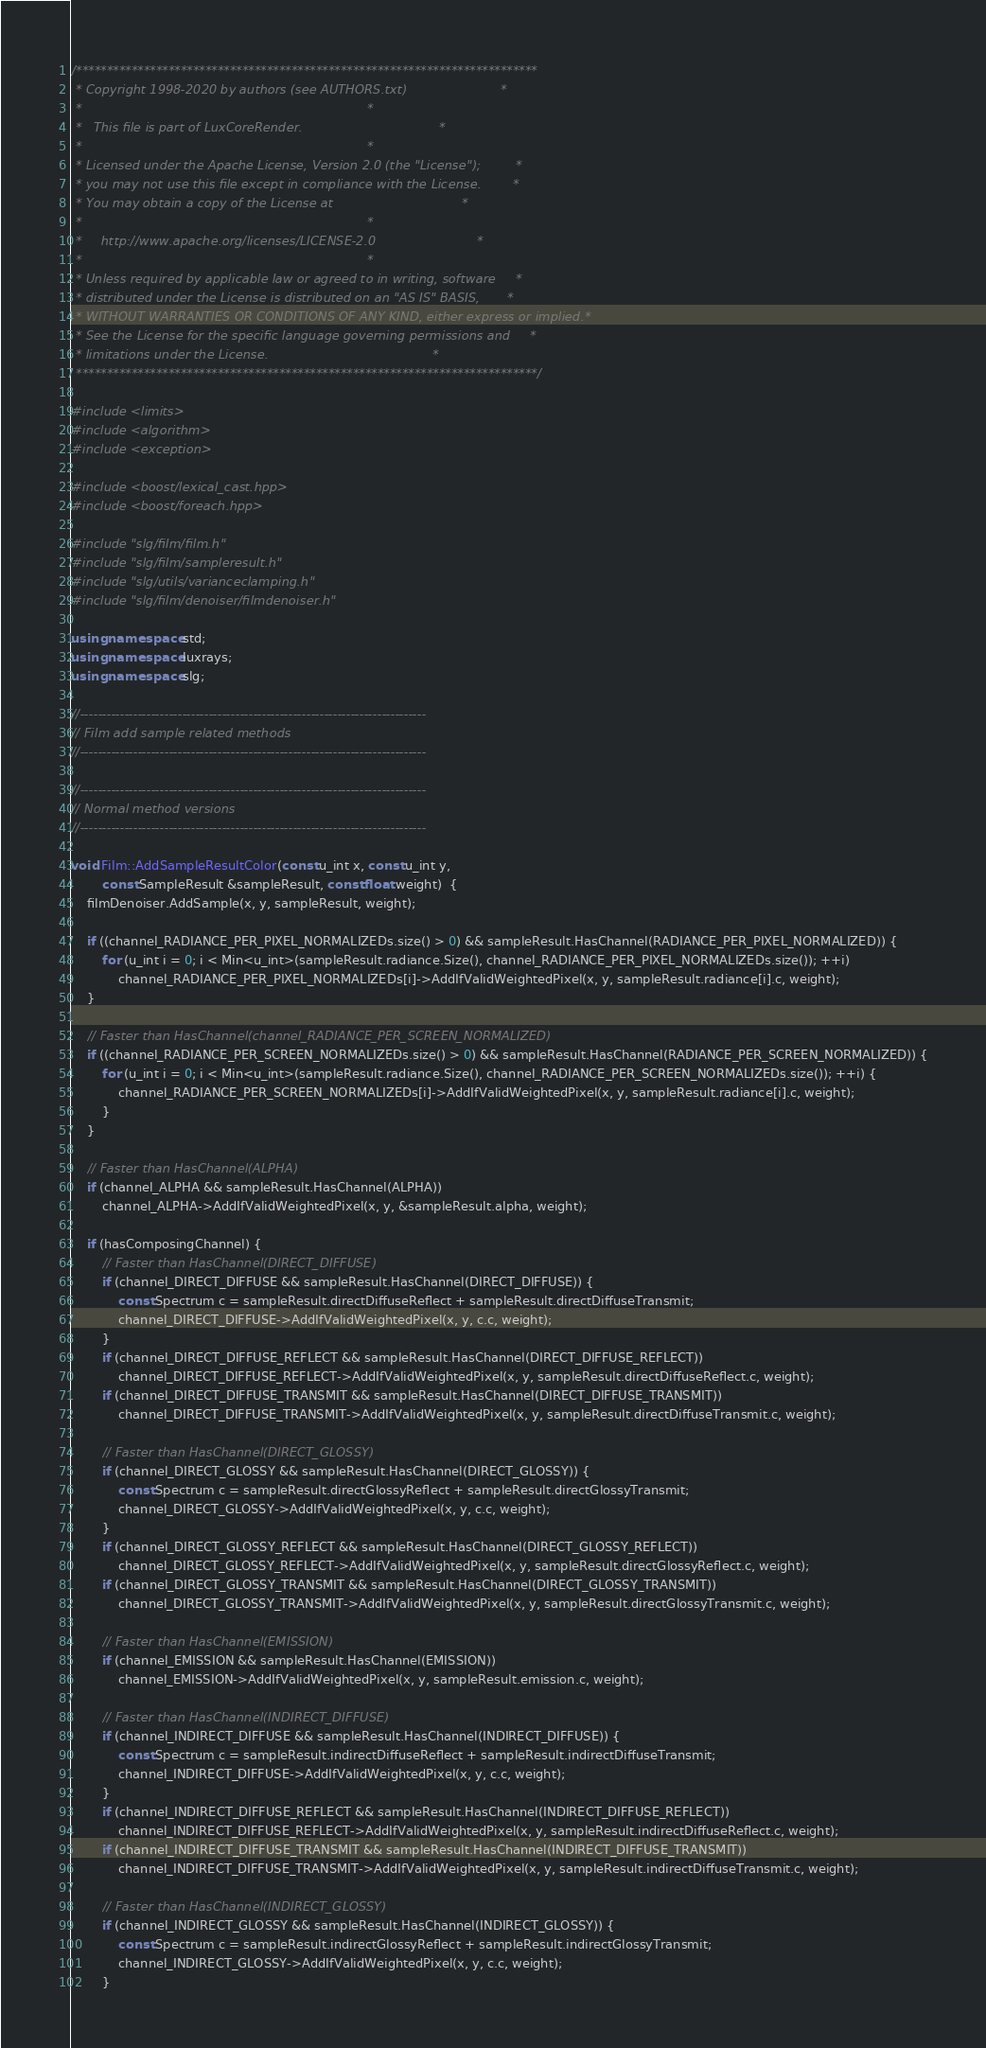<code> <loc_0><loc_0><loc_500><loc_500><_C++_>/***************************************************************************
 * Copyright 1998-2020 by authors (see AUTHORS.txt)                        *
 *                                                                         *
 *   This file is part of LuxCoreRender.                                   *
 *                                                                         *
 * Licensed under the Apache License, Version 2.0 (the "License");         *
 * you may not use this file except in compliance with the License.        *
 * You may obtain a copy of the License at                                 *
 *                                                                         *
 *     http://www.apache.org/licenses/LICENSE-2.0                          *
 *                                                                         *
 * Unless required by applicable law or agreed to in writing, software     *
 * distributed under the License is distributed on an "AS IS" BASIS,       *
 * WITHOUT WARRANTIES OR CONDITIONS OF ANY KIND, either express or implied.*
 * See the License for the specific language governing permissions and     *
 * limitations under the License.                                          *
 ***************************************************************************/

#include <limits>
#include <algorithm>
#include <exception>

#include <boost/lexical_cast.hpp>
#include <boost/foreach.hpp>

#include "slg/film/film.h"
#include "slg/film/sampleresult.h"
#include "slg/utils/varianceclamping.h"
#include "slg/film/denoiser/filmdenoiser.h"

using namespace std;
using namespace luxrays;
using namespace slg;

//------------------------------------------------------------------------------
// Film add sample related methods
//------------------------------------------------------------------------------

//------------------------------------------------------------------------------
// Normal method versions
//------------------------------------------------------------------------------

void Film::AddSampleResultColor(const u_int x, const u_int y,
		const SampleResult &sampleResult, const float weight)  {
	filmDenoiser.AddSample(x, y, sampleResult, weight);

	if ((channel_RADIANCE_PER_PIXEL_NORMALIZEDs.size() > 0) && sampleResult.HasChannel(RADIANCE_PER_PIXEL_NORMALIZED)) {
		for (u_int i = 0; i < Min<u_int>(sampleResult.radiance.Size(), channel_RADIANCE_PER_PIXEL_NORMALIZEDs.size()); ++i)
			channel_RADIANCE_PER_PIXEL_NORMALIZEDs[i]->AddIfValidWeightedPixel(x, y, sampleResult.radiance[i].c, weight);
	}

	// Faster than HasChannel(channel_RADIANCE_PER_SCREEN_NORMALIZED)
	if ((channel_RADIANCE_PER_SCREEN_NORMALIZEDs.size() > 0) && sampleResult.HasChannel(RADIANCE_PER_SCREEN_NORMALIZED)) {
		for (u_int i = 0; i < Min<u_int>(sampleResult.radiance.Size(), channel_RADIANCE_PER_SCREEN_NORMALIZEDs.size()); ++i) {
			channel_RADIANCE_PER_SCREEN_NORMALIZEDs[i]->AddIfValidWeightedPixel(x, y, sampleResult.radiance[i].c, weight);
		}
	}

	// Faster than HasChannel(ALPHA)
	if (channel_ALPHA && sampleResult.HasChannel(ALPHA))
		channel_ALPHA->AddIfValidWeightedPixel(x, y, &sampleResult.alpha, weight);

	if (hasComposingChannel) {
		// Faster than HasChannel(DIRECT_DIFFUSE)
		if (channel_DIRECT_DIFFUSE && sampleResult.HasChannel(DIRECT_DIFFUSE)) {
			const Spectrum c = sampleResult.directDiffuseReflect + sampleResult.directDiffuseTransmit;
			channel_DIRECT_DIFFUSE->AddIfValidWeightedPixel(x, y, c.c, weight);
		}
		if (channel_DIRECT_DIFFUSE_REFLECT && sampleResult.HasChannel(DIRECT_DIFFUSE_REFLECT))
			channel_DIRECT_DIFFUSE_REFLECT->AddIfValidWeightedPixel(x, y, sampleResult.directDiffuseReflect.c, weight);
		if (channel_DIRECT_DIFFUSE_TRANSMIT && sampleResult.HasChannel(DIRECT_DIFFUSE_TRANSMIT))
			channel_DIRECT_DIFFUSE_TRANSMIT->AddIfValidWeightedPixel(x, y, sampleResult.directDiffuseTransmit.c, weight);

		// Faster than HasChannel(DIRECT_GLOSSY)
		if (channel_DIRECT_GLOSSY && sampleResult.HasChannel(DIRECT_GLOSSY)) {
			const Spectrum c = sampleResult.directGlossyReflect + sampleResult.directGlossyTransmit;
			channel_DIRECT_GLOSSY->AddIfValidWeightedPixel(x, y, c.c, weight);
		}
		if (channel_DIRECT_GLOSSY_REFLECT && sampleResult.HasChannel(DIRECT_GLOSSY_REFLECT))
			channel_DIRECT_GLOSSY_REFLECT->AddIfValidWeightedPixel(x, y, sampleResult.directGlossyReflect.c, weight);
		if (channel_DIRECT_GLOSSY_TRANSMIT && sampleResult.HasChannel(DIRECT_GLOSSY_TRANSMIT))
			channel_DIRECT_GLOSSY_TRANSMIT->AddIfValidWeightedPixel(x, y, sampleResult.directGlossyTransmit.c, weight);

		// Faster than HasChannel(EMISSION)
		if (channel_EMISSION && sampleResult.HasChannel(EMISSION))
			channel_EMISSION->AddIfValidWeightedPixel(x, y, sampleResult.emission.c, weight);

		// Faster than HasChannel(INDIRECT_DIFFUSE)
		if (channel_INDIRECT_DIFFUSE && sampleResult.HasChannel(INDIRECT_DIFFUSE)) {
			const Spectrum c = sampleResult.indirectDiffuseReflect + sampleResult.indirectDiffuseTransmit;
			channel_INDIRECT_DIFFUSE->AddIfValidWeightedPixel(x, y, c.c, weight);
		}
		if (channel_INDIRECT_DIFFUSE_REFLECT && sampleResult.HasChannel(INDIRECT_DIFFUSE_REFLECT))
			channel_INDIRECT_DIFFUSE_REFLECT->AddIfValidWeightedPixel(x, y, sampleResult.indirectDiffuseReflect.c, weight);
		if (channel_INDIRECT_DIFFUSE_TRANSMIT && sampleResult.HasChannel(INDIRECT_DIFFUSE_TRANSMIT))
			channel_INDIRECT_DIFFUSE_TRANSMIT->AddIfValidWeightedPixel(x, y, sampleResult.indirectDiffuseTransmit.c, weight);

		// Faster than HasChannel(INDIRECT_GLOSSY)
		if (channel_INDIRECT_GLOSSY && sampleResult.HasChannel(INDIRECT_GLOSSY)) {
			const Spectrum c = sampleResult.indirectGlossyReflect + sampleResult.indirectGlossyTransmit;
			channel_INDIRECT_GLOSSY->AddIfValidWeightedPixel(x, y, c.c, weight);
		}</code> 